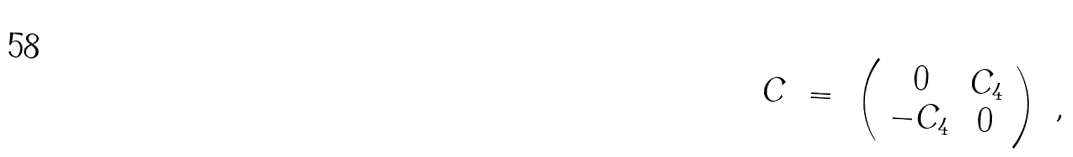Convert formula to latex. <formula><loc_0><loc_0><loc_500><loc_500>C \ = \ \left ( \begin{array} { c c } 0 & C _ { 4 } \\ - C _ { 4 } & 0 \end{array} \right ) \ ,</formula> 